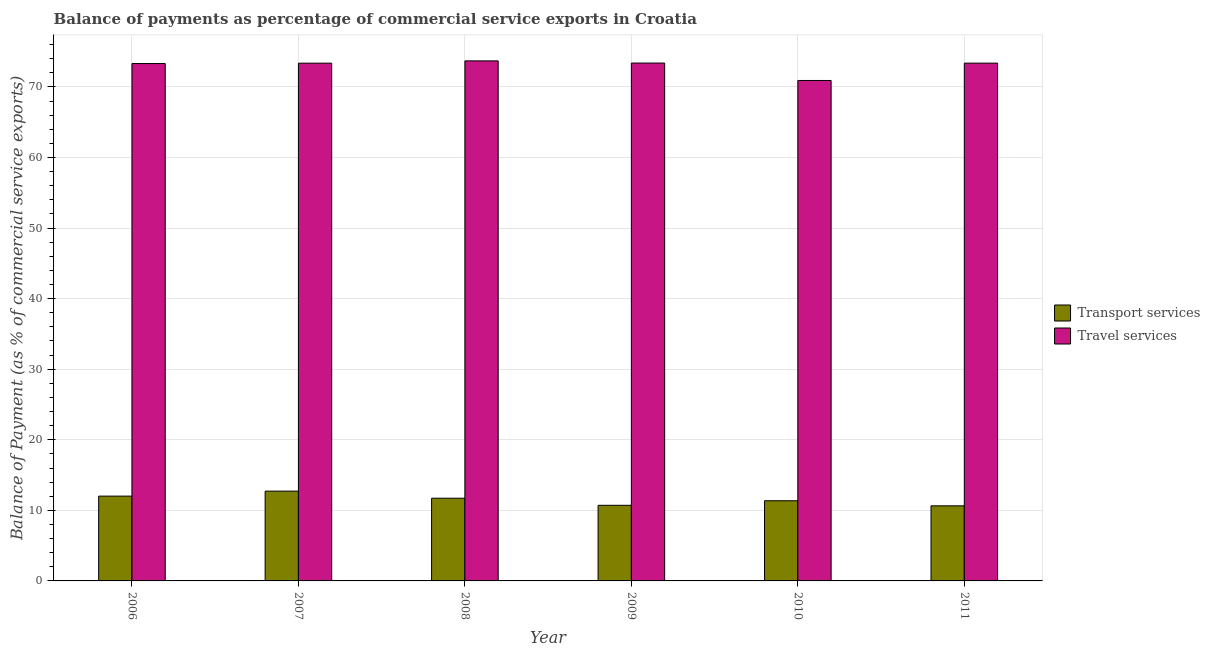Are the number of bars per tick equal to the number of legend labels?
Offer a terse response. Yes. Are the number of bars on each tick of the X-axis equal?
Ensure brevity in your answer.  Yes. How many bars are there on the 6th tick from the right?
Offer a very short reply. 2. What is the balance of payments of travel services in 2010?
Ensure brevity in your answer.  70.91. Across all years, what is the maximum balance of payments of travel services?
Offer a very short reply. 73.69. Across all years, what is the minimum balance of payments of transport services?
Ensure brevity in your answer.  10.64. In which year was the balance of payments of travel services minimum?
Offer a very short reply. 2010. What is the total balance of payments of travel services in the graph?
Make the answer very short. 438.01. What is the difference between the balance of payments of transport services in 2007 and that in 2008?
Provide a succinct answer. 1. What is the difference between the balance of payments of travel services in 2011 and the balance of payments of transport services in 2007?
Your response must be concise. 0. What is the average balance of payments of travel services per year?
Give a very brief answer. 73. In the year 2009, what is the difference between the balance of payments of travel services and balance of payments of transport services?
Your answer should be very brief. 0. What is the ratio of the balance of payments of travel services in 2007 to that in 2011?
Offer a terse response. 1. Is the balance of payments of transport services in 2009 less than that in 2011?
Your response must be concise. No. What is the difference between the highest and the second highest balance of payments of transport services?
Offer a terse response. 0.71. What is the difference between the highest and the lowest balance of payments of travel services?
Ensure brevity in your answer.  2.78. Is the sum of the balance of payments of travel services in 2009 and 2011 greater than the maximum balance of payments of transport services across all years?
Make the answer very short. Yes. What does the 1st bar from the left in 2009 represents?
Give a very brief answer. Transport services. What does the 2nd bar from the right in 2011 represents?
Your response must be concise. Transport services. Are all the bars in the graph horizontal?
Give a very brief answer. No. What is the difference between two consecutive major ticks on the Y-axis?
Give a very brief answer. 10. Are the values on the major ticks of Y-axis written in scientific E-notation?
Your answer should be compact. No. What is the title of the graph?
Your answer should be very brief. Balance of payments as percentage of commercial service exports in Croatia. Does "Lower secondary rate" appear as one of the legend labels in the graph?
Keep it short and to the point. No. What is the label or title of the X-axis?
Offer a very short reply. Year. What is the label or title of the Y-axis?
Your answer should be compact. Balance of Payment (as % of commercial service exports). What is the Balance of Payment (as % of commercial service exports) in Transport services in 2006?
Give a very brief answer. 12.02. What is the Balance of Payment (as % of commercial service exports) of Travel services in 2006?
Provide a short and direct response. 73.31. What is the Balance of Payment (as % of commercial service exports) in Transport services in 2007?
Offer a terse response. 12.72. What is the Balance of Payment (as % of commercial service exports) of Travel services in 2007?
Your answer should be very brief. 73.36. What is the Balance of Payment (as % of commercial service exports) in Transport services in 2008?
Give a very brief answer. 11.72. What is the Balance of Payment (as % of commercial service exports) in Travel services in 2008?
Your answer should be very brief. 73.69. What is the Balance of Payment (as % of commercial service exports) in Transport services in 2009?
Ensure brevity in your answer.  10.72. What is the Balance of Payment (as % of commercial service exports) in Travel services in 2009?
Your answer should be compact. 73.38. What is the Balance of Payment (as % of commercial service exports) in Transport services in 2010?
Provide a short and direct response. 11.36. What is the Balance of Payment (as % of commercial service exports) of Travel services in 2010?
Make the answer very short. 70.91. What is the Balance of Payment (as % of commercial service exports) of Transport services in 2011?
Ensure brevity in your answer.  10.64. What is the Balance of Payment (as % of commercial service exports) in Travel services in 2011?
Make the answer very short. 73.37. Across all years, what is the maximum Balance of Payment (as % of commercial service exports) in Transport services?
Offer a terse response. 12.72. Across all years, what is the maximum Balance of Payment (as % of commercial service exports) of Travel services?
Make the answer very short. 73.69. Across all years, what is the minimum Balance of Payment (as % of commercial service exports) in Transport services?
Provide a short and direct response. 10.64. Across all years, what is the minimum Balance of Payment (as % of commercial service exports) of Travel services?
Keep it short and to the point. 70.91. What is the total Balance of Payment (as % of commercial service exports) of Transport services in the graph?
Make the answer very short. 69.17. What is the total Balance of Payment (as % of commercial service exports) of Travel services in the graph?
Offer a terse response. 438.01. What is the difference between the Balance of Payment (as % of commercial service exports) in Transport services in 2006 and that in 2007?
Provide a short and direct response. -0.71. What is the difference between the Balance of Payment (as % of commercial service exports) of Travel services in 2006 and that in 2007?
Ensure brevity in your answer.  -0.05. What is the difference between the Balance of Payment (as % of commercial service exports) in Transport services in 2006 and that in 2008?
Offer a terse response. 0.3. What is the difference between the Balance of Payment (as % of commercial service exports) in Travel services in 2006 and that in 2008?
Provide a succinct answer. -0.38. What is the difference between the Balance of Payment (as % of commercial service exports) in Transport services in 2006 and that in 2009?
Your answer should be compact. 1.3. What is the difference between the Balance of Payment (as % of commercial service exports) of Travel services in 2006 and that in 2009?
Give a very brief answer. -0.07. What is the difference between the Balance of Payment (as % of commercial service exports) of Transport services in 2006 and that in 2010?
Provide a succinct answer. 0.66. What is the difference between the Balance of Payment (as % of commercial service exports) of Travel services in 2006 and that in 2010?
Provide a short and direct response. 2.4. What is the difference between the Balance of Payment (as % of commercial service exports) of Transport services in 2006 and that in 2011?
Your answer should be very brief. 1.38. What is the difference between the Balance of Payment (as % of commercial service exports) in Travel services in 2006 and that in 2011?
Offer a very short reply. -0.06. What is the difference between the Balance of Payment (as % of commercial service exports) of Travel services in 2007 and that in 2008?
Provide a short and direct response. -0.32. What is the difference between the Balance of Payment (as % of commercial service exports) of Transport services in 2007 and that in 2009?
Offer a very short reply. 2.01. What is the difference between the Balance of Payment (as % of commercial service exports) of Travel services in 2007 and that in 2009?
Make the answer very short. -0.02. What is the difference between the Balance of Payment (as % of commercial service exports) in Transport services in 2007 and that in 2010?
Give a very brief answer. 1.37. What is the difference between the Balance of Payment (as % of commercial service exports) of Travel services in 2007 and that in 2010?
Provide a short and direct response. 2.45. What is the difference between the Balance of Payment (as % of commercial service exports) of Transport services in 2007 and that in 2011?
Your response must be concise. 2.08. What is the difference between the Balance of Payment (as % of commercial service exports) of Travel services in 2007 and that in 2011?
Your answer should be compact. -0. What is the difference between the Balance of Payment (as % of commercial service exports) of Transport services in 2008 and that in 2009?
Keep it short and to the point. 1. What is the difference between the Balance of Payment (as % of commercial service exports) in Travel services in 2008 and that in 2009?
Offer a very short reply. 0.31. What is the difference between the Balance of Payment (as % of commercial service exports) in Transport services in 2008 and that in 2010?
Offer a very short reply. 0.36. What is the difference between the Balance of Payment (as % of commercial service exports) of Travel services in 2008 and that in 2010?
Your answer should be compact. 2.78. What is the difference between the Balance of Payment (as % of commercial service exports) in Transport services in 2008 and that in 2011?
Offer a very short reply. 1.08. What is the difference between the Balance of Payment (as % of commercial service exports) in Travel services in 2008 and that in 2011?
Your answer should be very brief. 0.32. What is the difference between the Balance of Payment (as % of commercial service exports) in Transport services in 2009 and that in 2010?
Your answer should be compact. -0.64. What is the difference between the Balance of Payment (as % of commercial service exports) of Travel services in 2009 and that in 2010?
Offer a terse response. 2.47. What is the difference between the Balance of Payment (as % of commercial service exports) in Transport services in 2009 and that in 2011?
Your response must be concise. 0.08. What is the difference between the Balance of Payment (as % of commercial service exports) in Travel services in 2009 and that in 2011?
Ensure brevity in your answer.  0.01. What is the difference between the Balance of Payment (as % of commercial service exports) in Transport services in 2010 and that in 2011?
Provide a succinct answer. 0.72. What is the difference between the Balance of Payment (as % of commercial service exports) of Travel services in 2010 and that in 2011?
Provide a short and direct response. -2.46. What is the difference between the Balance of Payment (as % of commercial service exports) of Transport services in 2006 and the Balance of Payment (as % of commercial service exports) of Travel services in 2007?
Give a very brief answer. -61.35. What is the difference between the Balance of Payment (as % of commercial service exports) in Transport services in 2006 and the Balance of Payment (as % of commercial service exports) in Travel services in 2008?
Keep it short and to the point. -61.67. What is the difference between the Balance of Payment (as % of commercial service exports) in Transport services in 2006 and the Balance of Payment (as % of commercial service exports) in Travel services in 2009?
Keep it short and to the point. -61.36. What is the difference between the Balance of Payment (as % of commercial service exports) in Transport services in 2006 and the Balance of Payment (as % of commercial service exports) in Travel services in 2010?
Provide a succinct answer. -58.89. What is the difference between the Balance of Payment (as % of commercial service exports) of Transport services in 2006 and the Balance of Payment (as % of commercial service exports) of Travel services in 2011?
Provide a succinct answer. -61.35. What is the difference between the Balance of Payment (as % of commercial service exports) in Transport services in 2007 and the Balance of Payment (as % of commercial service exports) in Travel services in 2008?
Offer a very short reply. -60.96. What is the difference between the Balance of Payment (as % of commercial service exports) in Transport services in 2007 and the Balance of Payment (as % of commercial service exports) in Travel services in 2009?
Offer a terse response. -60.65. What is the difference between the Balance of Payment (as % of commercial service exports) of Transport services in 2007 and the Balance of Payment (as % of commercial service exports) of Travel services in 2010?
Make the answer very short. -58.19. What is the difference between the Balance of Payment (as % of commercial service exports) of Transport services in 2007 and the Balance of Payment (as % of commercial service exports) of Travel services in 2011?
Ensure brevity in your answer.  -60.64. What is the difference between the Balance of Payment (as % of commercial service exports) in Transport services in 2008 and the Balance of Payment (as % of commercial service exports) in Travel services in 2009?
Make the answer very short. -61.66. What is the difference between the Balance of Payment (as % of commercial service exports) in Transport services in 2008 and the Balance of Payment (as % of commercial service exports) in Travel services in 2010?
Your answer should be very brief. -59.19. What is the difference between the Balance of Payment (as % of commercial service exports) in Transport services in 2008 and the Balance of Payment (as % of commercial service exports) in Travel services in 2011?
Your answer should be very brief. -61.65. What is the difference between the Balance of Payment (as % of commercial service exports) in Transport services in 2009 and the Balance of Payment (as % of commercial service exports) in Travel services in 2010?
Make the answer very short. -60.19. What is the difference between the Balance of Payment (as % of commercial service exports) in Transport services in 2009 and the Balance of Payment (as % of commercial service exports) in Travel services in 2011?
Give a very brief answer. -62.65. What is the difference between the Balance of Payment (as % of commercial service exports) in Transport services in 2010 and the Balance of Payment (as % of commercial service exports) in Travel services in 2011?
Your answer should be very brief. -62.01. What is the average Balance of Payment (as % of commercial service exports) of Transport services per year?
Provide a succinct answer. 11.53. What is the average Balance of Payment (as % of commercial service exports) of Travel services per year?
Offer a terse response. 73. In the year 2006, what is the difference between the Balance of Payment (as % of commercial service exports) of Transport services and Balance of Payment (as % of commercial service exports) of Travel services?
Your answer should be very brief. -61.29. In the year 2007, what is the difference between the Balance of Payment (as % of commercial service exports) in Transport services and Balance of Payment (as % of commercial service exports) in Travel services?
Your answer should be very brief. -60.64. In the year 2008, what is the difference between the Balance of Payment (as % of commercial service exports) in Transport services and Balance of Payment (as % of commercial service exports) in Travel services?
Keep it short and to the point. -61.97. In the year 2009, what is the difference between the Balance of Payment (as % of commercial service exports) in Transport services and Balance of Payment (as % of commercial service exports) in Travel services?
Provide a succinct answer. -62.66. In the year 2010, what is the difference between the Balance of Payment (as % of commercial service exports) of Transport services and Balance of Payment (as % of commercial service exports) of Travel services?
Your answer should be compact. -59.55. In the year 2011, what is the difference between the Balance of Payment (as % of commercial service exports) of Transport services and Balance of Payment (as % of commercial service exports) of Travel services?
Provide a succinct answer. -62.73. What is the ratio of the Balance of Payment (as % of commercial service exports) of Travel services in 2006 to that in 2007?
Your answer should be compact. 1. What is the ratio of the Balance of Payment (as % of commercial service exports) of Transport services in 2006 to that in 2008?
Offer a terse response. 1.03. What is the ratio of the Balance of Payment (as % of commercial service exports) in Travel services in 2006 to that in 2008?
Offer a very short reply. 0.99. What is the ratio of the Balance of Payment (as % of commercial service exports) of Transport services in 2006 to that in 2009?
Your answer should be compact. 1.12. What is the ratio of the Balance of Payment (as % of commercial service exports) of Transport services in 2006 to that in 2010?
Give a very brief answer. 1.06. What is the ratio of the Balance of Payment (as % of commercial service exports) of Travel services in 2006 to that in 2010?
Provide a succinct answer. 1.03. What is the ratio of the Balance of Payment (as % of commercial service exports) of Transport services in 2006 to that in 2011?
Ensure brevity in your answer.  1.13. What is the ratio of the Balance of Payment (as % of commercial service exports) in Transport services in 2007 to that in 2008?
Your answer should be very brief. 1.09. What is the ratio of the Balance of Payment (as % of commercial service exports) in Transport services in 2007 to that in 2009?
Offer a terse response. 1.19. What is the ratio of the Balance of Payment (as % of commercial service exports) in Transport services in 2007 to that in 2010?
Ensure brevity in your answer.  1.12. What is the ratio of the Balance of Payment (as % of commercial service exports) of Travel services in 2007 to that in 2010?
Make the answer very short. 1.03. What is the ratio of the Balance of Payment (as % of commercial service exports) in Transport services in 2007 to that in 2011?
Your response must be concise. 1.2. What is the ratio of the Balance of Payment (as % of commercial service exports) in Travel services in 2007 to that in 2011?
Ensure brevity in your answer.  1. What is the ratio of the Balance of Payment (as % of commercial service exports) of Transport services in 2008 to that in 2009?
Offer a very short reply. 1.09. What is the ratio of the Balance of Payment (as % of commercial service exports) of Travel services in 2008 to that in 2009?
Give a very brief answer. 1. What is the ratio of the Balance of Payment (as % of commercial service exports) of Transport services in 2008 to that in 2010?
Offer a terse response. 1.03. What is the ratio of the Balance of Payment (as % of commercial service exports) in Travel services in 2008 to that in 2010?
Provide a succinct answer. 1.04. What is the ratio of the Balance of Payment (as % of commercial service exports) in Transport services in 2008 to that in 2011?
Give a very brief answer. 1.1. What is the ratio of the Balance of Payment (as % of commercial service exports) of Transport services in 2009 to that in 2010?
Provide a short and direct response. 0.94. What is the ratio of the Balance of Payment (as % of commercial service exports) in Travel services in 2009 to that in 2010?
Offer a terse response. 1.03. What is the ratio of the Balance of Payment (as % of commercial service exports) of Transport services in 2010 to that in 2011?
Keep it short and to the point. 1.07. What is the ratio of the Balance of Payment (as % of commercial service exports) of Travel services in 2010 to that in 2011?
Make the answer very short. 0.97. What is the difference between the highest and the second highest Balance of Payment (as % of commercial service exports) in Transport services?
Keep it short and to the point. 0.71. What is the difference between the highest and the second highest Balance of Payment (as % of commercial service exports) in Travel services?
Ensure brevity in your answer.  0.31. What is the difference between the highest and the lowest Balance of Payment (as % of commercial service exports) in Transport services?
Your answer should be compact. 2.08. What is the difference between the highest and the lowest Balance of Payment (as % of commercial service exports) in Travel services?
Your answer should be very brief. 2.78. 